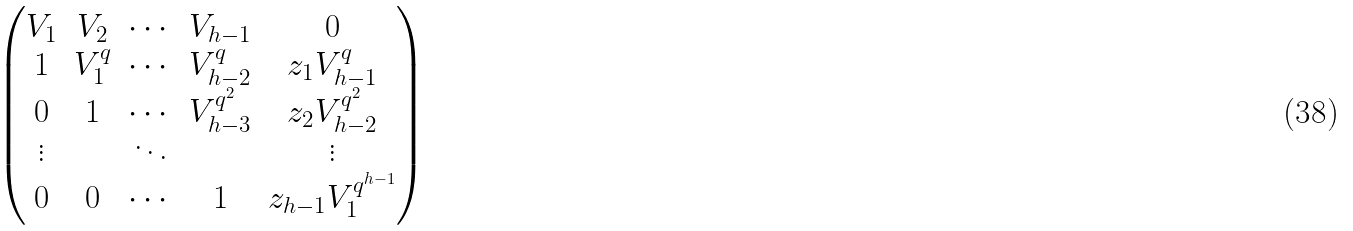Convert formula to latex. <formula><loc_0><loc_0><loc_500><loc_500>\begin{pmatrix} V _ { 1 } & V _ { 2 } & \cdots & V _ { h - 1 } & 0 \\ 1 & V _ { 1 } ^ { q } & \cdots & V _ { h - 2 } ^ { q } & z _ { 1 } V _ { h - 1 } ^ { q } \\ 0 & 1 & \cdots & V _ { h - 3 } ^ { q ^ { 2 } } & z _ { 2 } V _ { h - 2 } ^ { q ^ { 2 } } \\ \vdots & & \ddots & & \vdots \\ 0 & 0 & \cdots & 1 & z _ { h - 1 } V _ { 1 } ^ { q ^ { h - 1 } } \end{pmatrix}</formula> 